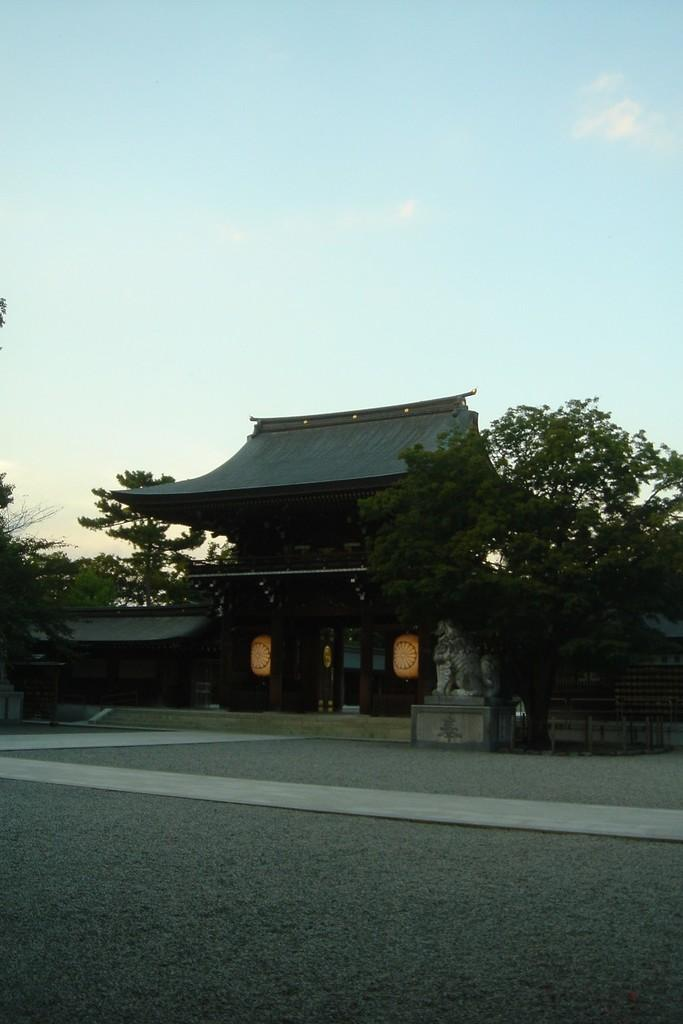What type of structure is present in the image? There is a house in the image. What other object can be seen in the image besides the house? There is a statue in the image. What type of vegetation is present in the image? There are trees in the image. What can be seen in the background of the image? The sky is visible in the background of the image. What is the grade of the hot square in the image? There is no hot square present in the image. 